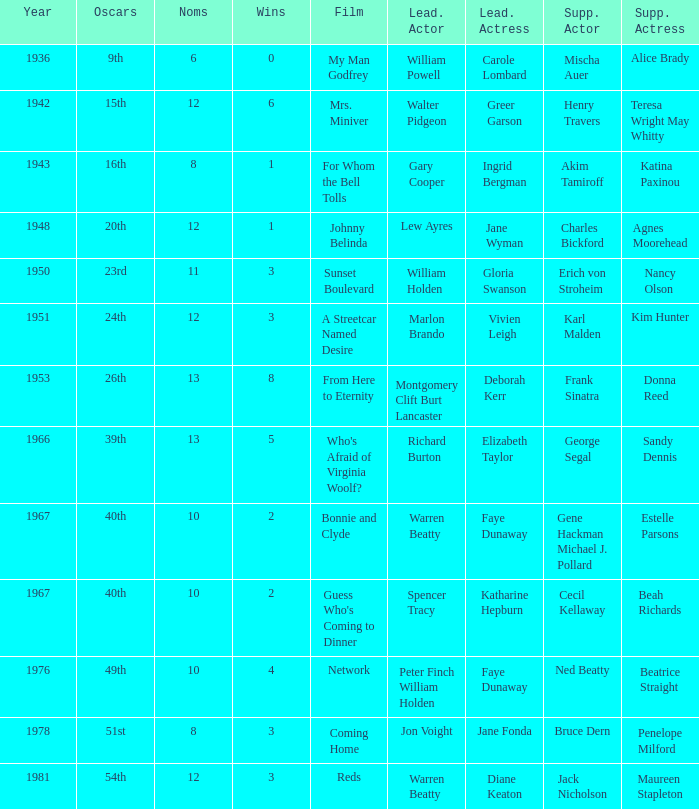Who was the leading actor in the film with a supporting actor named Cecil Kellaway? Spencer Tracy. 